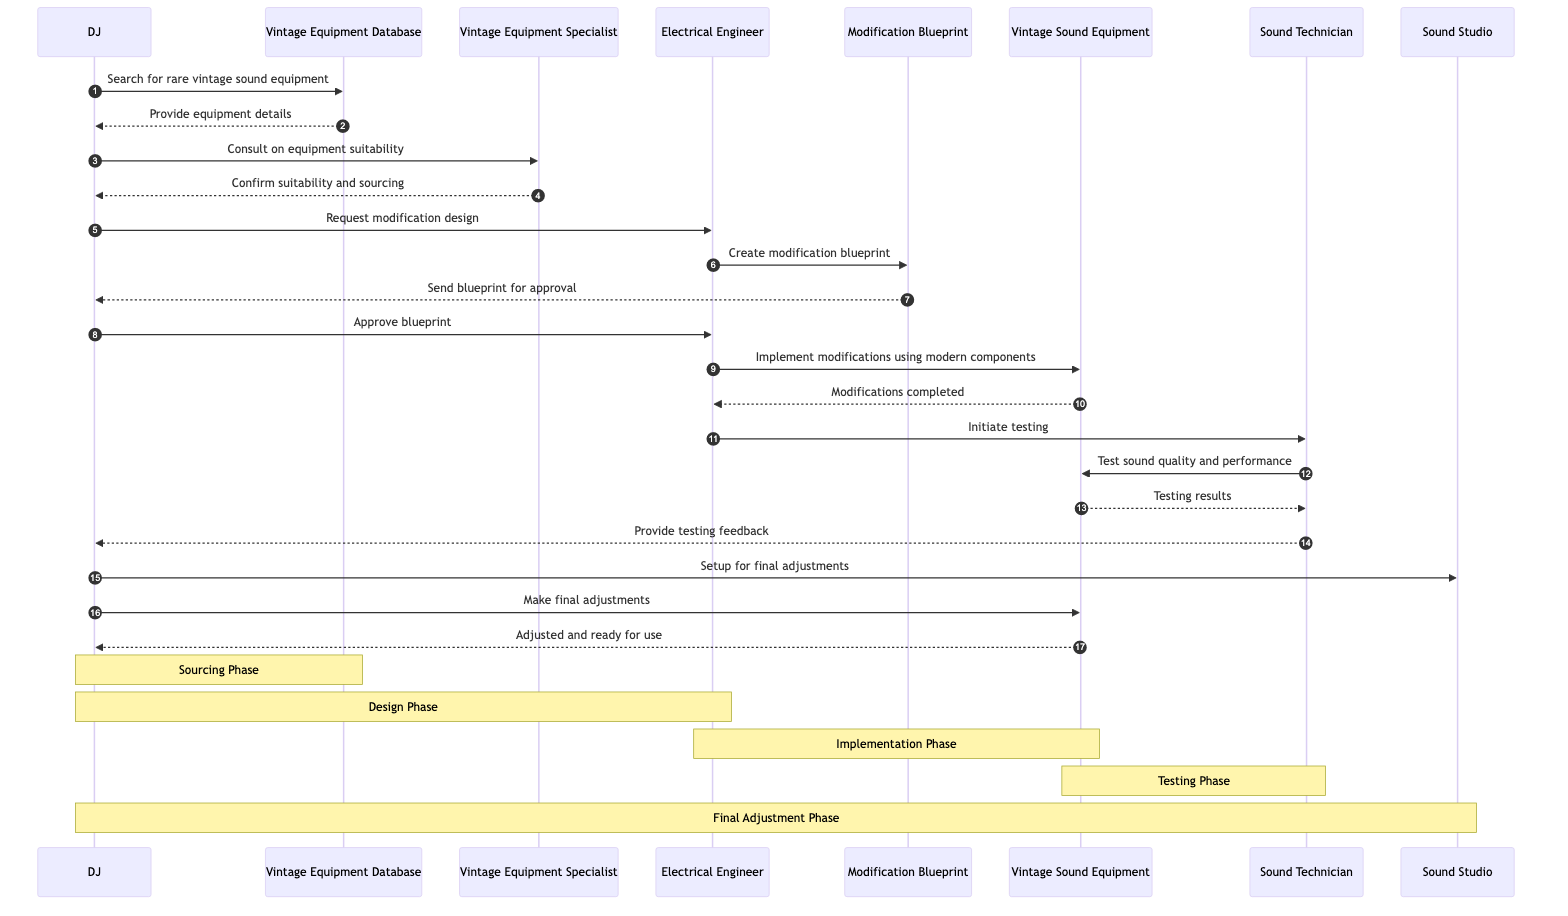What's the first action taken by the DJ? The DJ initiates the process by sending a message to the Vintage Equipment Database requesting to search for rare vintage sound equipment.
Answer: Search for rare vintage sound equipment How many actors are involved in the sequence? The diagram includes four distinct actors: DJ, Vintage Equipment Specialist, Electrical Engineer, and Sound Technician.
Answer: Four What is created by the Electrical Engineer? The Electrical Engineer is tasked with creating the modification blueprint for the vintage sound equipment.
Answer: Modification blueprint What does the Sound Technician test? The Sound Technician tests the sound quality and performance of the Vintage Sound Equipment as part of the testing phase.
Answer: Sound quality and performance Which phase includes setup for final adjustments? The final adjustments are set up in the Final Adjustment Phase, during which the DJ organizes the Sound Studio for this task.
Answer: Final Adjustment Phase What is the purpose of the Vintage Equipment Specialist's consultation with the DJ? The purpose is to confirm the suitability of the vintage equipment and assist in its sourcing based on the DJ's needs.
Answer: Confirm suitability and sourcing During which phase are modifications implemented? Modifications are implemented during the Implementation Phase, where the Electrical Engineer modifies the Vintage Sound Equipment using modern components.
Answer: Implementation Phase How does the DJ respond to the modification blueprint? Upon receiving the blueprint from the Electrical Engineer, the DJ reviews it and responds by approving the design for modifications.
Answer: Approve blueprint What does the Vintage Sound Equipment become after final adjustments? After the DJ makes the final adjustments, the Vintage Sound Equipment is ready for use.
Answer: Adjusted and ready for use 